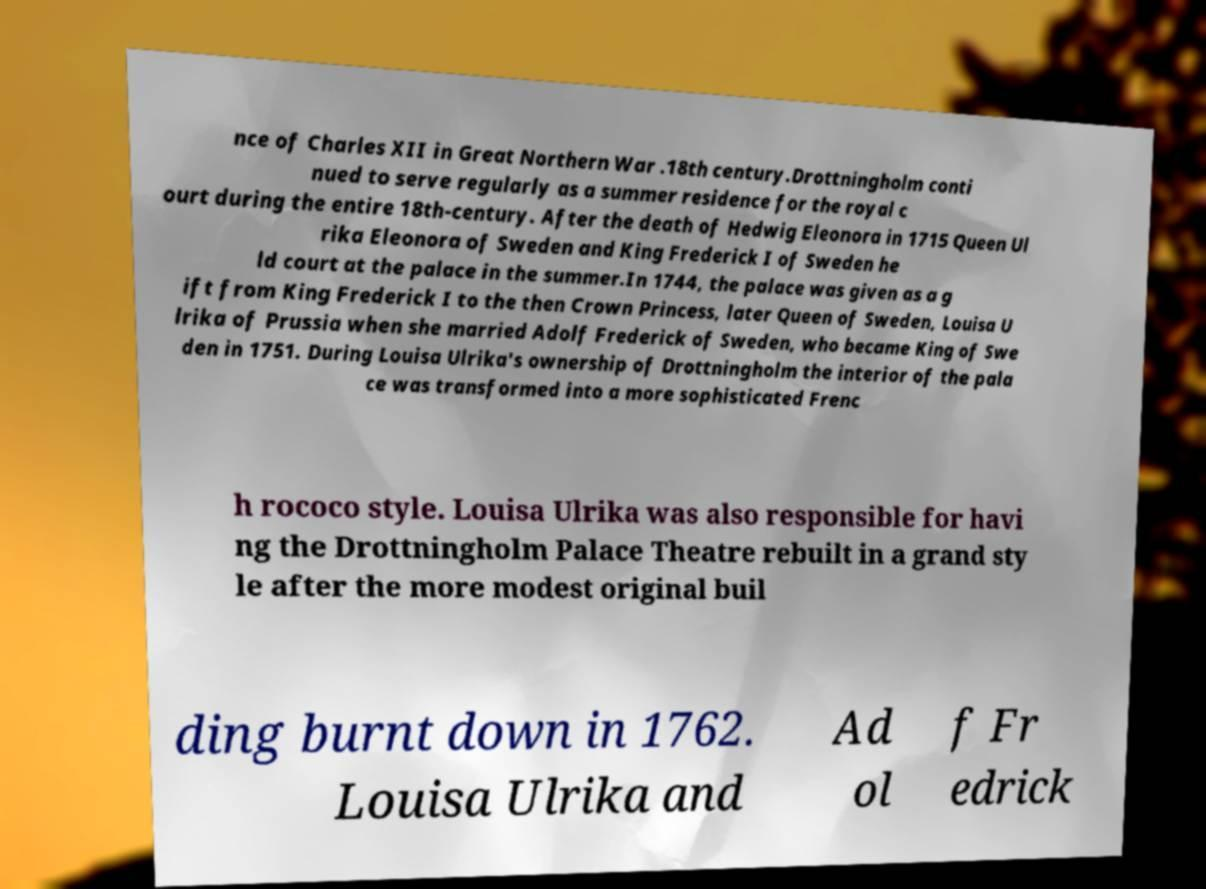Could you assist in decoding the text presented in this image and type it out clearly? nce of Charles XII in Great Northern War .18th century.Drottningholm conti nued to serve regularly as a summer residence for the royal c ourt during the entire 18th-century. After the death of Hedwig Eleonora in 1715 Queen Ul rika Eleonora of Sweden and King Frederick I of Sweden he ld court at the palace in the summer.In 1744, the palace was given as a g ift from King Frederick I to the then Crown Princess, later Queen of Sweden, Louisa U lrika of Prussia when she married Adolf Frederick of Sweden, who became King of Swe den in 1751. During Louisa Ulrika's ownership of Drottningholm the interior of the pala ce was transformed into a more sophisticated Frenc h rococo style. Louisa Ulrika was also responsible for havi ng the Drottningholm Palace Theatre rebuilt in a grand sty le after the more modest original buil ding burnt down in 1762. Louisa Ulrika and Ad ol f Fr edrick 